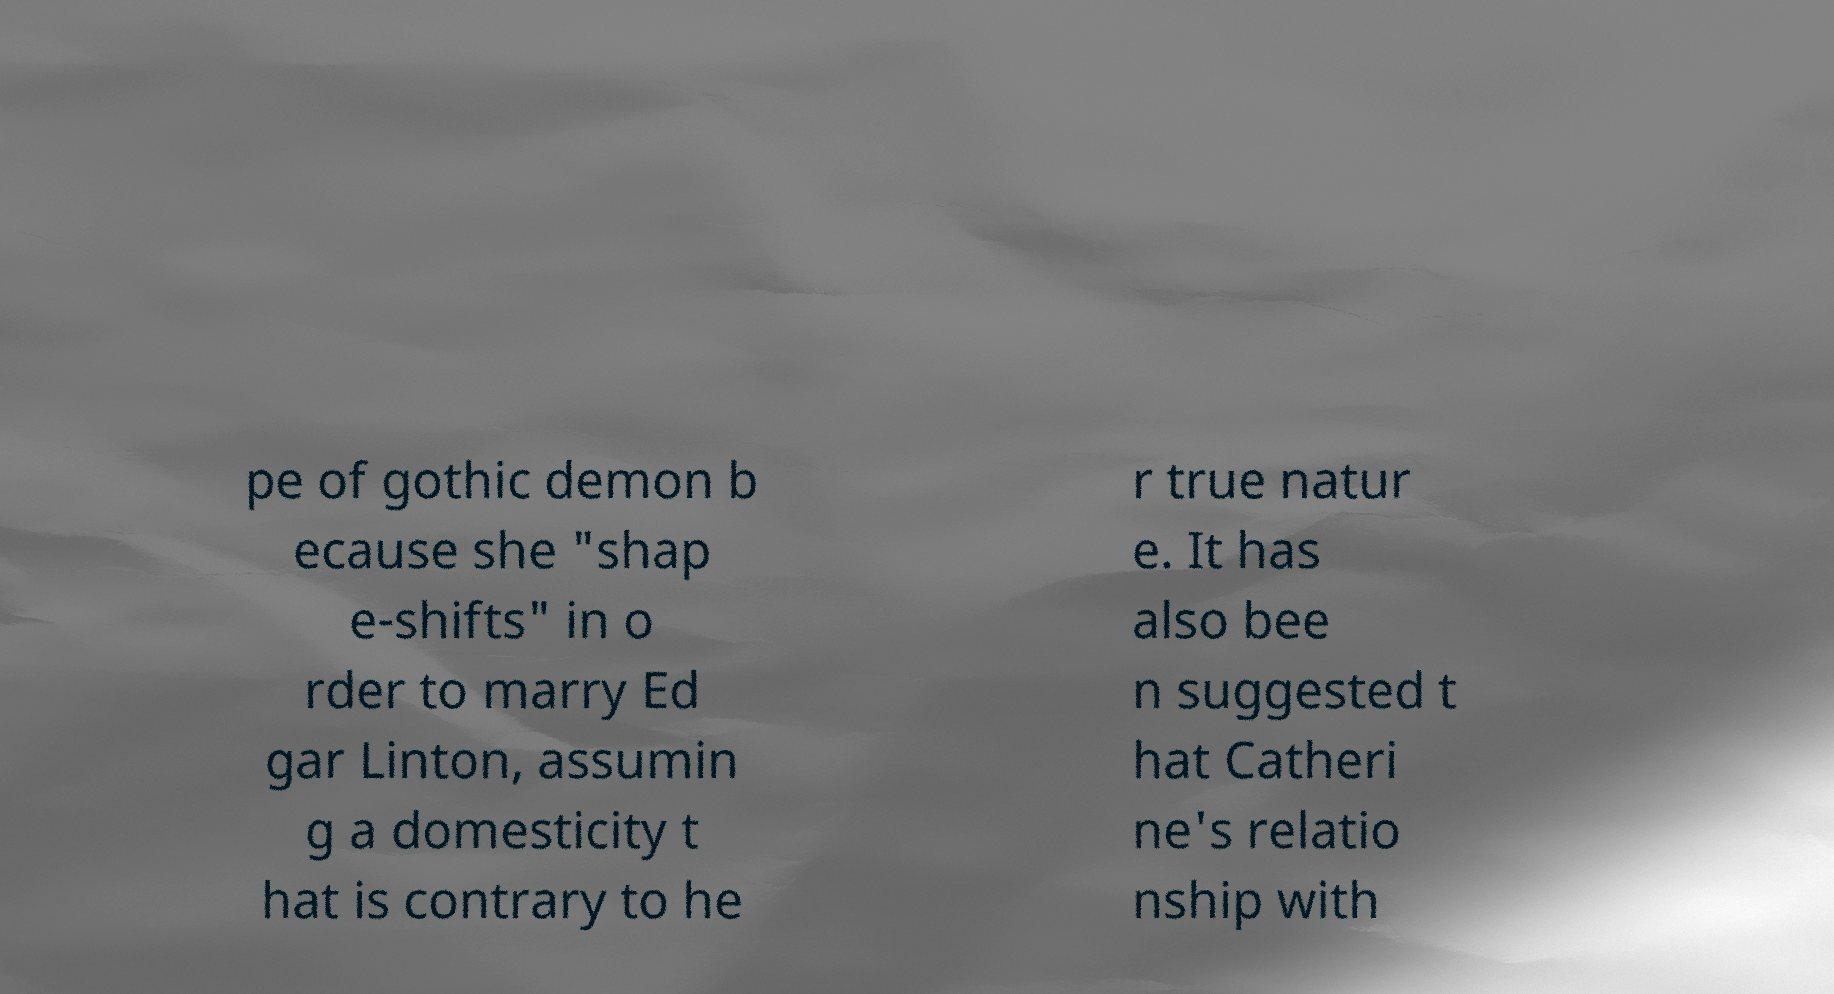For documentation purposes, I need the text within this image transcribed. Could you provide that? pe of gothic demon b ecause she "shap e-shifts" in o rder to marry Ed gar Linton, assumin g a domesticity t hat is contrary to he r true natur e. It has also bee n suggested t hat Catheri ne's relatio nship with 